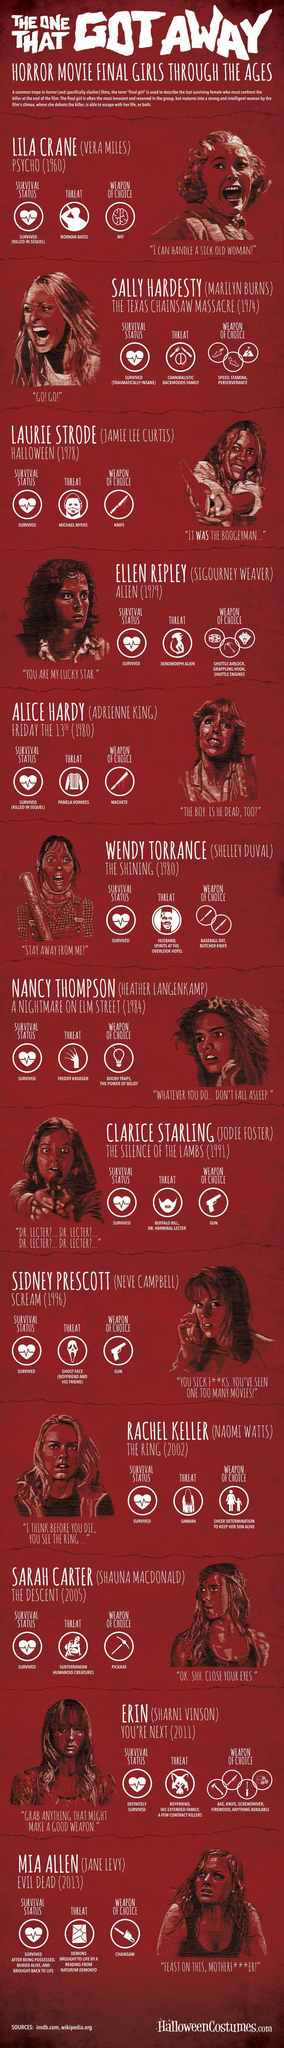What is the killing equipment used by Evil Dead?
Answer the question with a short phrase. Chainsaw What is the killing equipment used by the antagonist in Halloween? Knife How many weapons were used by the threat in Alien? 3 Whom was the threat to Sally Hardesty? Cannibalistic Backwoods Family Who portrayed the main role in Psycho? Vera Miles Who was the antagonist in Halloween? Michael Myers What was the second threat to Wendy Torrance? Spirits at the Overlook Hotel How many girls escaped from murder though they had high probability to get killed? 2 What is the killing equipment used by the antagonist in Friday the 13th? Machete What is the role of Norman Bates in the novel Psycho? Threat 